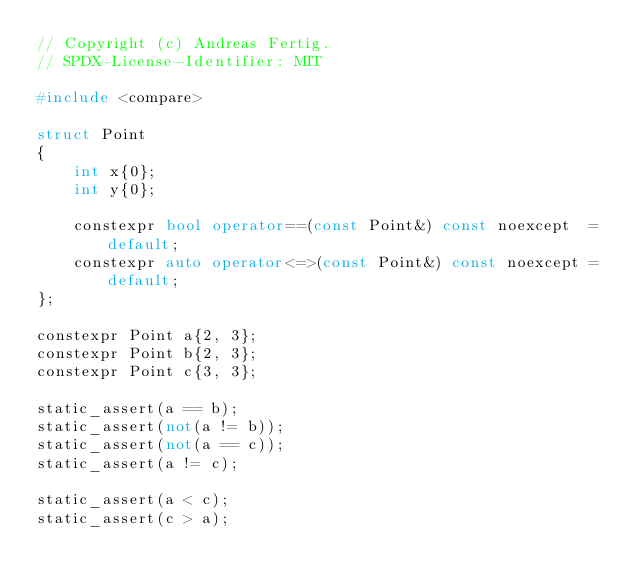<code> <loc_0><loc_0><loc_500><loc_500><_C++_>// Copyright (c) Andreas Fertig.
// SPDX-License-Identifier: MIT

#include <compare>

struct Point
{
    int x{0};
    int y{0};

    constexpr bool operator==(const Point&) const noexcept  = default;
    constexpr auto operator<=>(const Point&) const noexcept = default;
};

constexpr Point a{2, 3};
constexpr Point b{2, 3};
constexpr Point c{3, 3};

static_assert(a == b);
static_assert(not(a != b));
static_assert(not(a == c));
static_assert(a != c);

static_assert(a < c);
static_assert(c > a);
</code> 